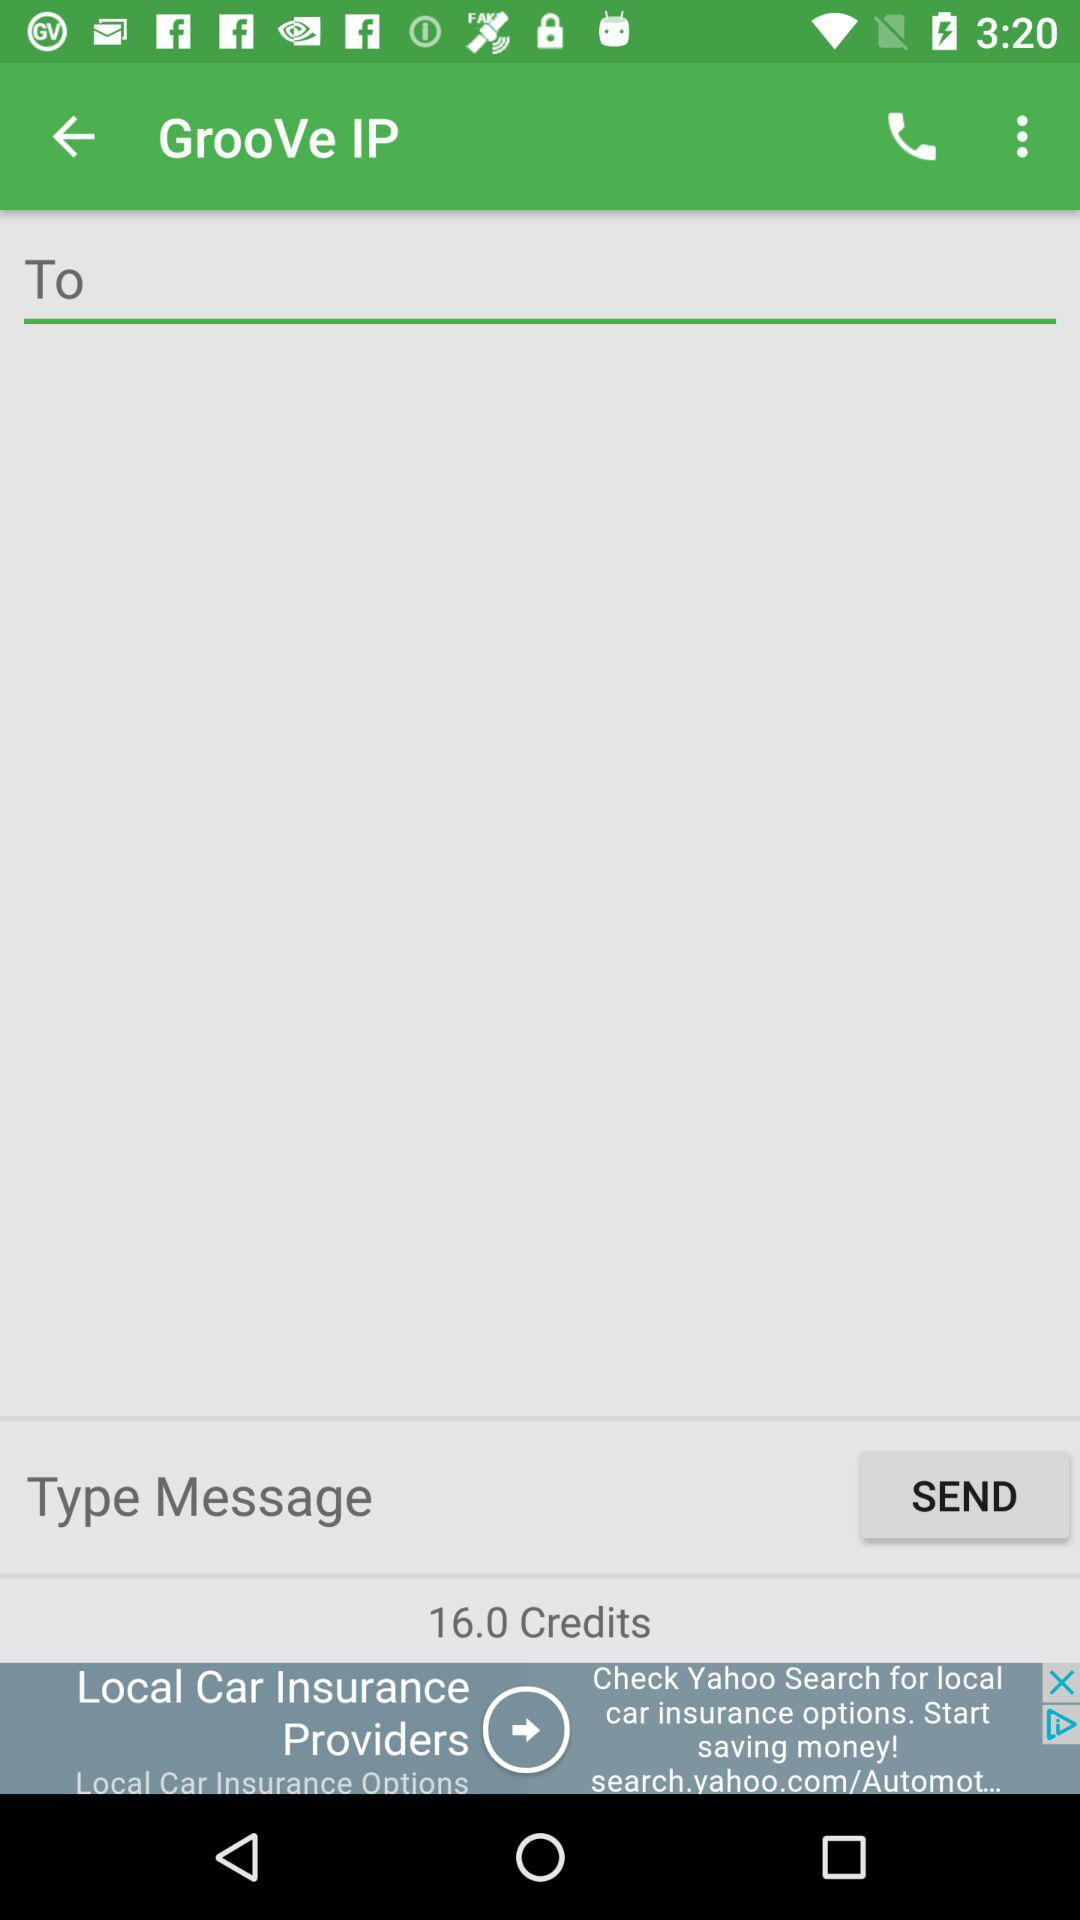How many credits are there? There are 16.0 credits. 